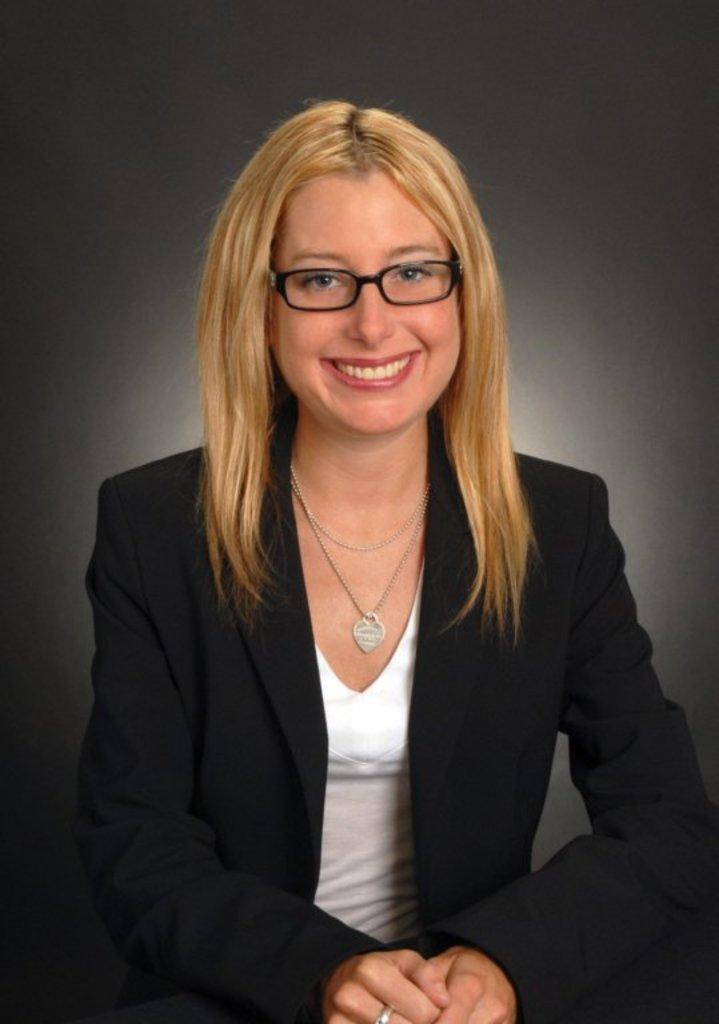Can you describe this image briefly? Here in this picture we can see a woman present over a place and we can see she is wearing a black colored coat, spectacles and smiling. 